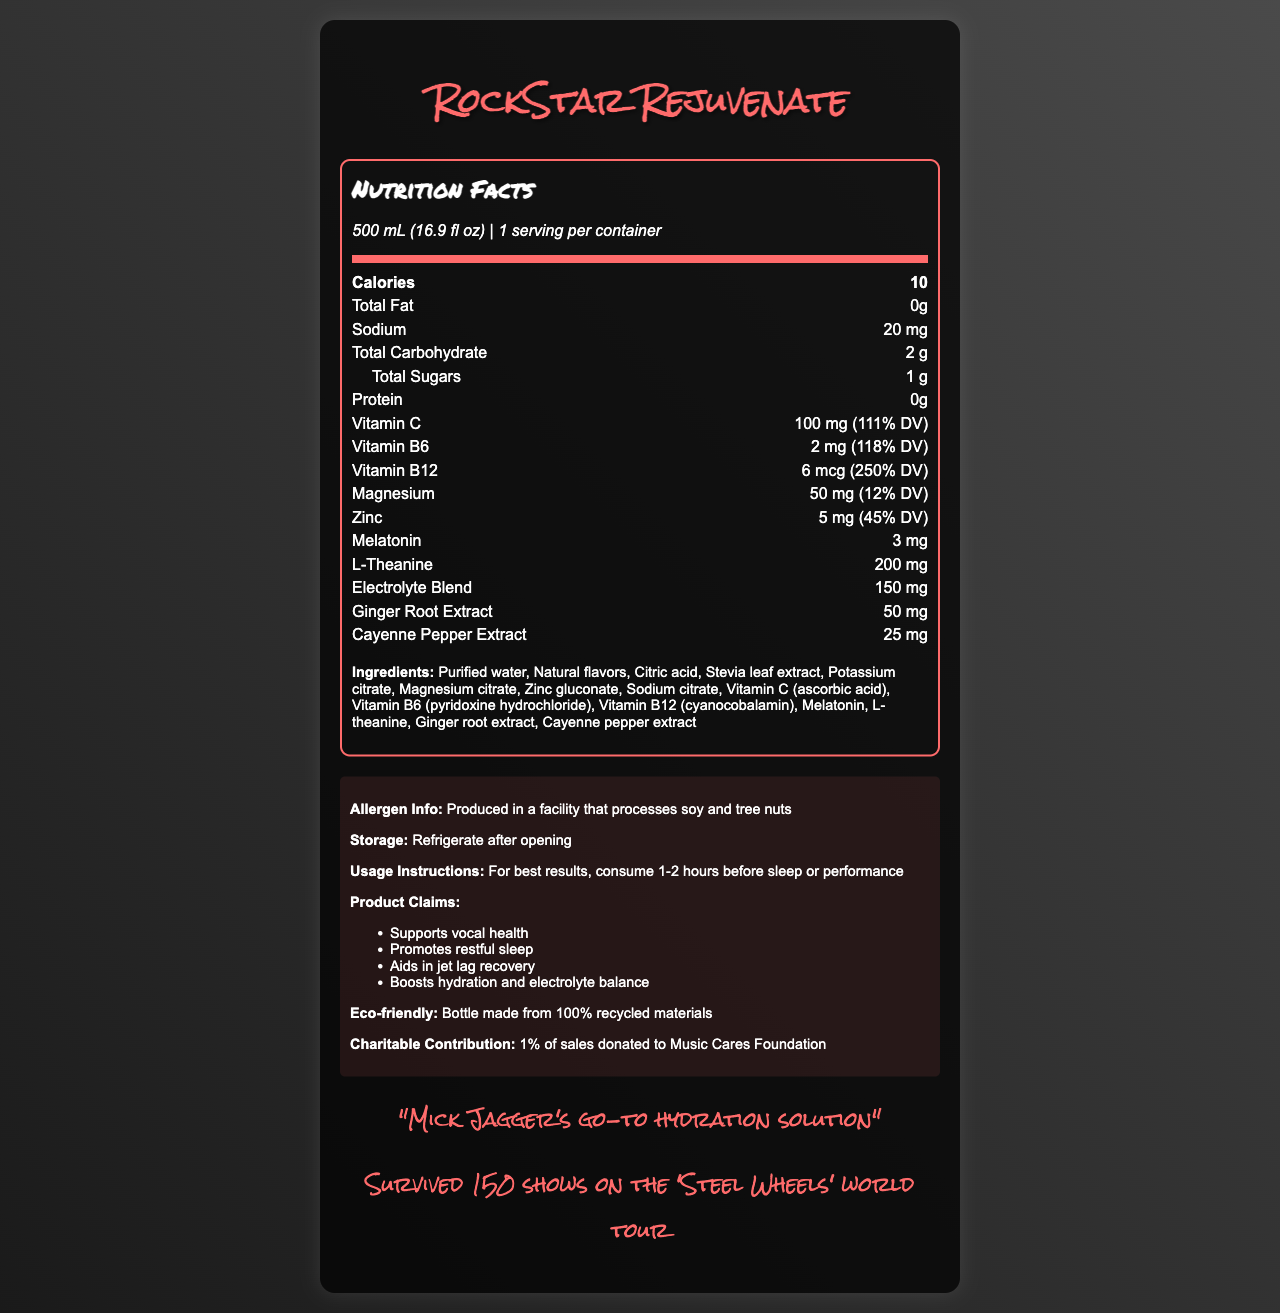what is the serving size of RockStar Rejuvenate? The serving size is listed in the document as 500 mL (16.9 fl oz).
Answer: 500 mL (16.9 fl oz) How many calories are in one serving of RockStar Rejuvenate? The calorie content per serving is listed as 10 calories.
Answer: 10 What percentage of the daily value (DV) of Vitamin C does RockStar Rejuvenate provide? The document lists that one serving provides 100 mg of Vitamin C, which is 111% of the daily value.
Answer: 111% Is RockStar Rejuvenate suitable for someone with a soy allergy? The allergen information states that it is produced in a facility that processes soy and tree nuts.
Answer: No What nutrient has the highest percentage of daily value in RockStar Rejuvenate? The document lists Vitamin B12 at 6 mcg with a 250% DV, which is the highest among the nutrients listed.
Answer: Vitamin B12 Which ingredient is used as a sweetener in RockStar Rejuvenate? Stevia leaf extract is listed among the ingredients and is known to be used as a sweetener.
Answer: Stevia leaf extract For optimal results, when should RockStar Rejuvenate be consumed? The usage instructions recommend consuming it 1-2 hours before sleep or performance.
Answer: 1-2 hours before sleep or performance What does the electrolyte blend contribute to RockStar Rejuvenate? The electrolyte blend contributes 150 mg, as noted in the nutrition label.
Answer: 150 mg What is one of the key benefits of RockStar Rejuvenate according to the product claims? A. Supports weight loss B. Improves digestion C. Supports vocal health D. Enhances muscle growth The product claims include "Supports vocal health" among other benefits.
Answer: C Which vitamin is present in the smallest quantity in RockStar Rejuvenate? A. Vitamin C B. Vitamin B6 C. Vitamin B12 D. All of these in equal amounts Vitamin B6 is present at 2 mg, which is less than the quantities of Vitamin C (100 mg) and Vitamin B12 (6 mcg).
Answer: B Does the product contain any melatonin? Melatonin is listed among the nutrients with a concentration of 3 mg.
Answer: Yes Is the bottle of RockStar Rejuvenate eco-friendly? The document states that the bottle is made from 100% recycled materials.
Answer: Yes how many ingredients are in RockStar Rejuvenate? The list of ingredients includes 14 different items.
Answer: 14 What is the charitable contribution made from the sales of RockStar Rejuvenate? The document notes that 1% of sales go to the Music Cares Foundation.
Answer: 1% of sales are donated to Music Cares Foundation Describe the main idea of the RockStar Rejuvenate Nutrition Facts document. The document details the nutrition facts of RockStar Rejuvenate, its ingredients, allergen information, usage instructions, and various product claims. It also highlights its eco-friendliness and charitable contributions.
Answer: RockStar Rejuvenate is a vitamin-enhanced bottled water tailored for rock stars to combat jet lag and vocal strain during tours. The drink has a low calorie count and includes a mix of vitamins, minerals, and other beneficial compounds like melatonin and L-theanine. The bottle is eco-friendly, and part of the sales is donated to a charitable foundation. What is the exact amount of Zinc in RockStar Rejuvenate? The nutrient row for Zinc lists it as containing 5 mg, which is 45% of the daily value.
Answer: 5 mg How many calories come from sugars in RockStar Rejuvenate? The document lists total sugars as 1 g, but it does not specify how many calories specifically come from these sugars.
Answer: Cannot be determined 